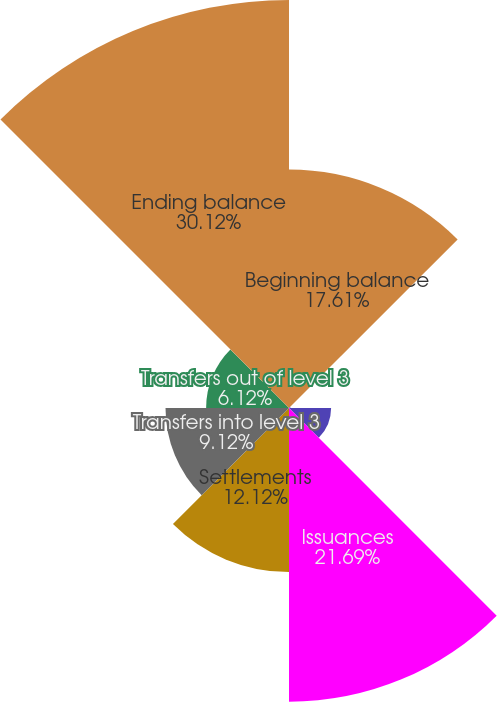Convert chart to OTSL. <chart><loc_0><loc_0><loc_500><loc_500><pie_chart><fcel>Beginning balance<fcel>Net realized gains/(losses)<fcel>Net unrealized gains/(losses)<fcel>Issuances<fcel>Settlements<fcel>Transfers into level 3<fcel>Transfers out of level 3<fcel>Ending balance<nl><fcel>17.61%<fcel>0.11%<fcel>3.11%<fcel>21.69%<fcel>12.12%<fcel>9.12%<fcel>6.12%<fcel>30.13%<nl></chart> 